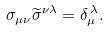Convert formula to latex. <formula><loc_0><loc_0><loc_500><loc_500>\sigma _ { \mu \nu } { \widetilde { \sigma } } ^ { \nu \lambda } = \delta _ { \mu } ^ { \, \lambda } .</formula> 